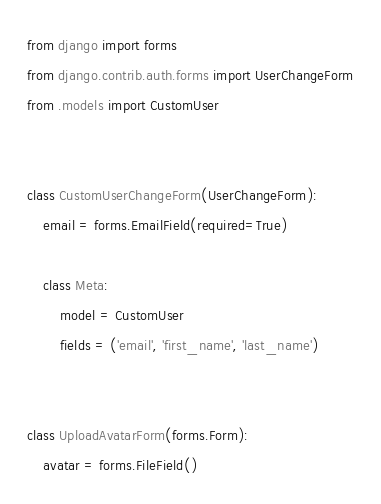Convert code to text. <code><loc_0><loc_0><loc_500><loc_500><_Python_>from django import forms
from django.contrib.auth.forms import UserChangeForm
from .models import CustomUser


class CustomUserChangeForm(UserChangeForm):
    email = forms.EmailField(required=True)

    class Meta:
        model = CustomUser
        fields = ('email', 'first_name', 'last_name')


class UploadAvatarForm(forms.Form):
    avatar = forms.FileField()
</code> 